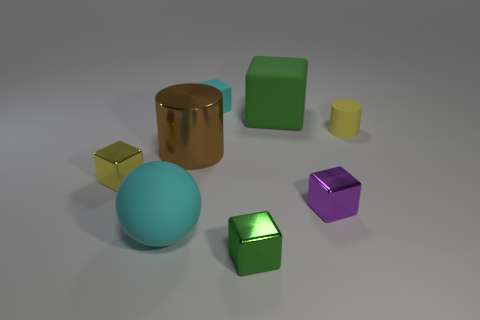Is there anything else of the same color as the big cylinder?
Your answer should be very brief. No. What is the shape of the small object that is the same material as the small cyan block?
Ensure brevity in your answer.  Cylinder. Do the cyan cube and the metallic cylinder have the same size?
Provide a succinct answer. No. Is the cylinder left of the yellow rubber cylinder made of the same material as the yellow block?
Offer a very short reply. Yes. Are there any other things that are made of the same material as the big cyan sphere?
Offer a terse response. Yes. How many cyan spheres are behind the purple thing that is in front of the tiny yellow object on the right side of the tiny green metal block?
Ensure brevity in your answer.  0. Is the shape of the shiny thing that is on the left side of the brown object the same as  the tiny yellow rubber object?
Offer a terse response. No. How many things are big cyan balls or shiny blocks on the left side of the tiny cyan rubber cube?
Keep it short and to the point. 2. Are there more large cylinders on the left side of the large cyan thing than large matte balls?
Your answer should be compact. No. Is the number of balls behind the large cylinder the same as the number of small yellow matte things in front of the yellow metallic block?
Offer a very short reply. Yes. 